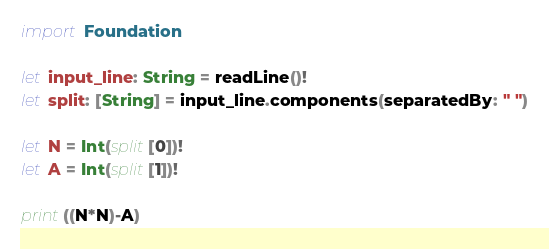Convert code to text. <code><loc_0><loc_0><loc_500><loc_500><_Swift_>import Foundation
 
let input_line: String = readLine()!
let split: [String] = input_line.components(separatedBy: " ")
 
let N = Int(split[0])!
let A = Int(split[1])!

print((N*N)-A)
</code> 